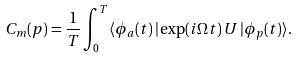Convert formula to latex. <formula><loc_0><loc_0><loc_500><loc_500>C _ { m } ( { p } ) = \frac { 1 } { T } \int _ { 0 } ^ { T } \langle \phi _ { a } ( t ) \, | \exp ( i \Omega t ) \, U \, | \phi _ { p } ( t ) \rangle .</formula> 